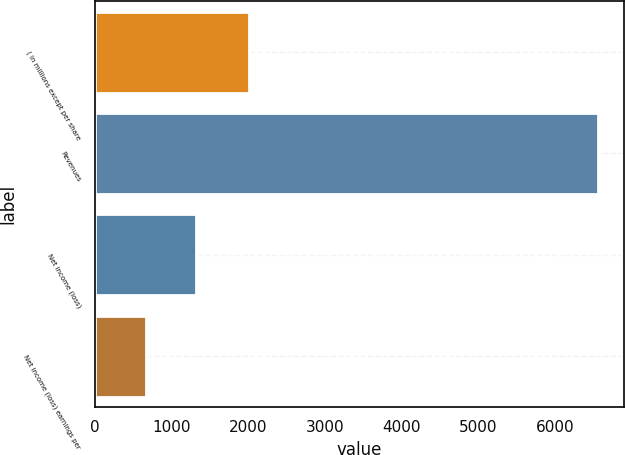Convert chart. <chart><loc_0><loc_0><loc_500><loc_500><bar_chart><fcel>( in millions except per share<fcel>Revenues<fcel>Net income (loss)<fcel>Net income (loss) earnings per<nl><fcel>2008<fcel>6569<fcel>1315.49<fcel>658.8<nl></chart> 